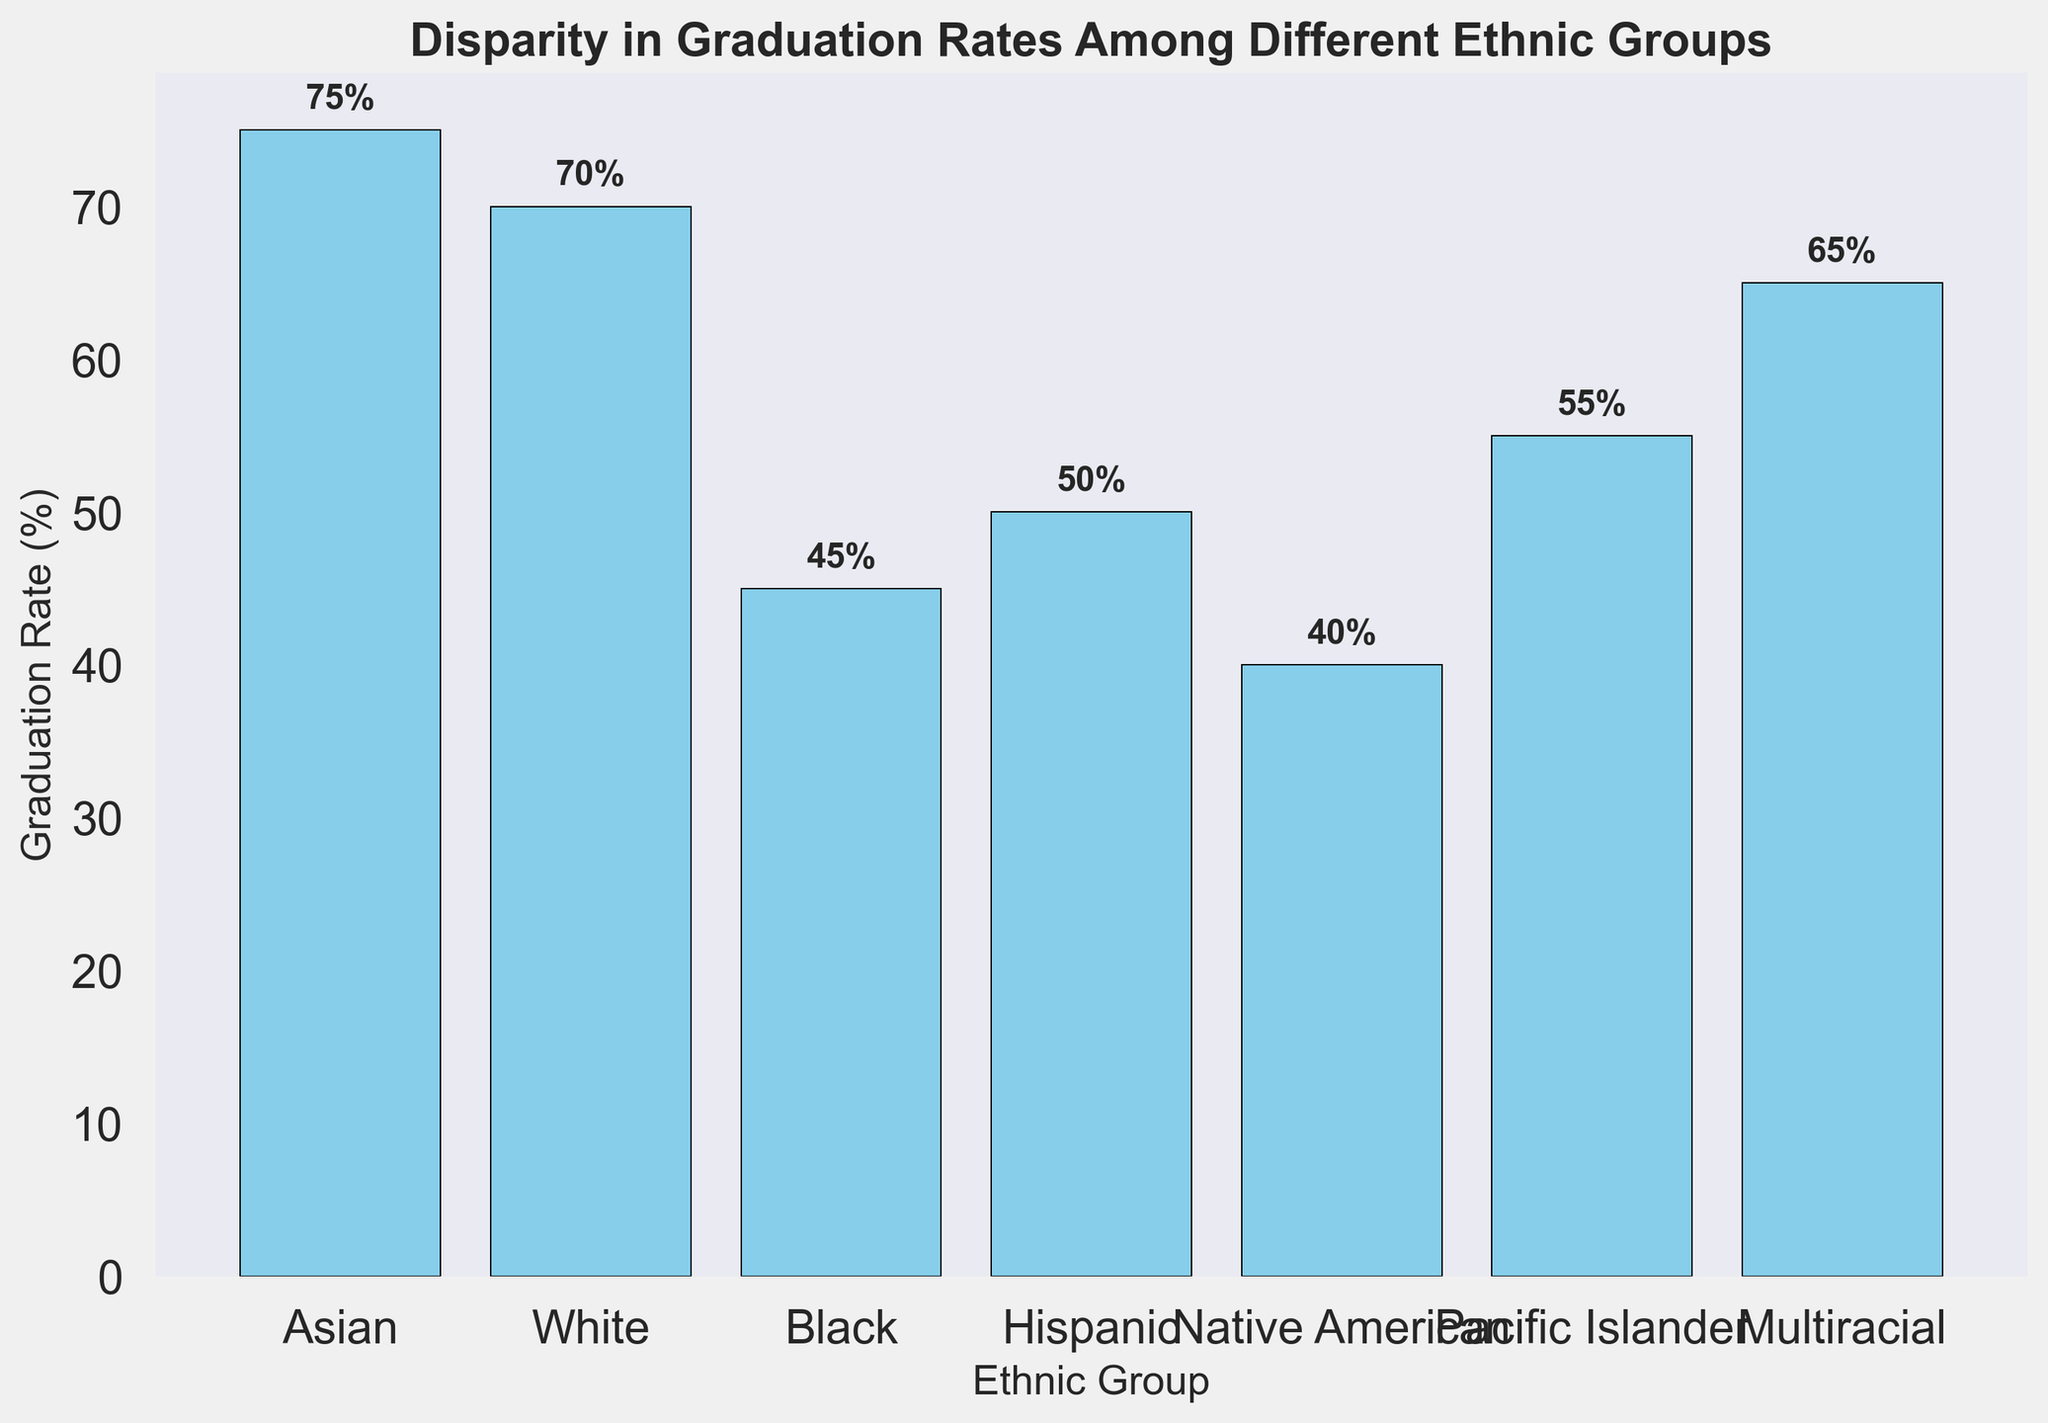What is the graduation rate for the Black ethnic group? The bar labeled 'Black' represents the graduation rate for this ethnic group. By looking at the height of the bar and the annotated value, we see it is 45%.
Answer: 45% Which ethnic group has the highest graduation rate? By comparing the heights of all the bars, the tallest bar corresponds to the 'Asian' group. The annotated value shows 75%, which is the highest graduation rate among the groups listed.
Answer: Asian How much higher is the graduation rate for Pacific Islanders compared to Native Americans? The bar for the Pacific Islander group shows a graduation rate of 55%, while the bar for the Native American group shows 40%. The difference is calculated as 55% - 40% = 15%.
Answer: 15% Between which two ethnic groups is the difference in graduation rates the smallest? To find the smallest difference, we compare the graduation rates between all pairs of adjacent bars. The smallest difference is between White (70%) and Multiracial (65%), with a difference of 5%.
Answer: White and Multiracial What is the combined graduation rate for Black and Hispanic ethnic groups? The graduation rates for Black and Hispanic groups are 45% and 50%, respectively. Adding these together gives 45% + 50% = 95%.
Answer: 95% What is the average graduation rate across all ethnic groups? The graduation rates are 75%, 70%, 45%, 50%, 40%, 55%, and 65%. Summing these rates: 75 + 70 + 45 + 50 + 40 + 55 + 65 = 400. Dividing by the number of groups (7) gives an average of 400 / 7 ≈ 57.14%.
Answer: 57.14% Which ethnic group has the lowest graduation rate? The shortest bar represents the Native American group, with a graduation rate of 40%, which is the lowest among all listed groups.
Answer: Native American How does the graduation rate for Hispanic compare to the median graduation rate of all groups? The graduation rates sorted are 40%, 45%, 50%, 55%, 65%, 70%, 75%. The median value is the middle number in this sorted list, which is 55%. The Hispanic graduation rate is 50%, which is less than the median.
Answer: Less than What is the range of graduation rates across the ethnic groups? The highest graduation rate is 75% (Asian) and the lowest is 40% (Native American). The range is calculated as 75% - 40% = 35%.
Answer: 35% If you combine the graduation rates of Asian and White groups, what percentage of the total graduation rate for all ethnic groups do they represent? Total graduation rate for all groups is 400%. Combined rate for Asian and White is 75% + 70% = 145%. The percentage they represent is (145 / 400) * 100% = 36.25%.
Answer: 36.25% 